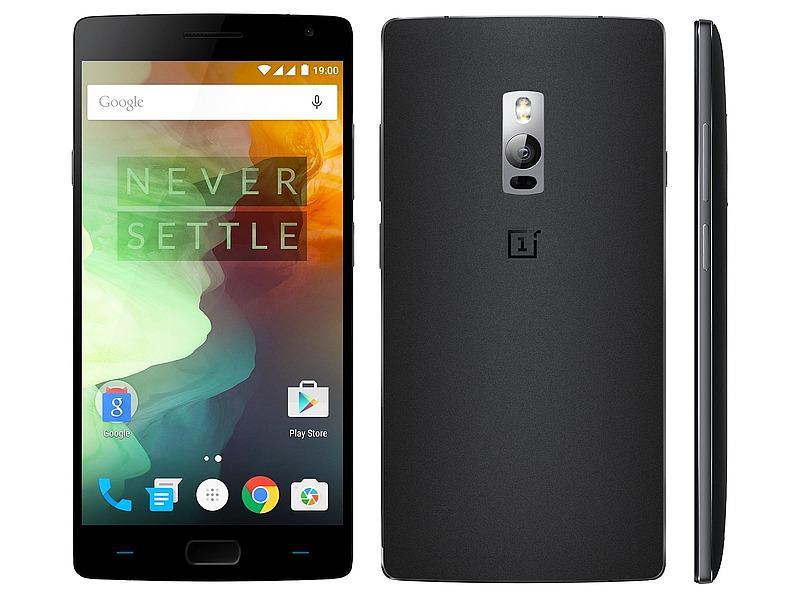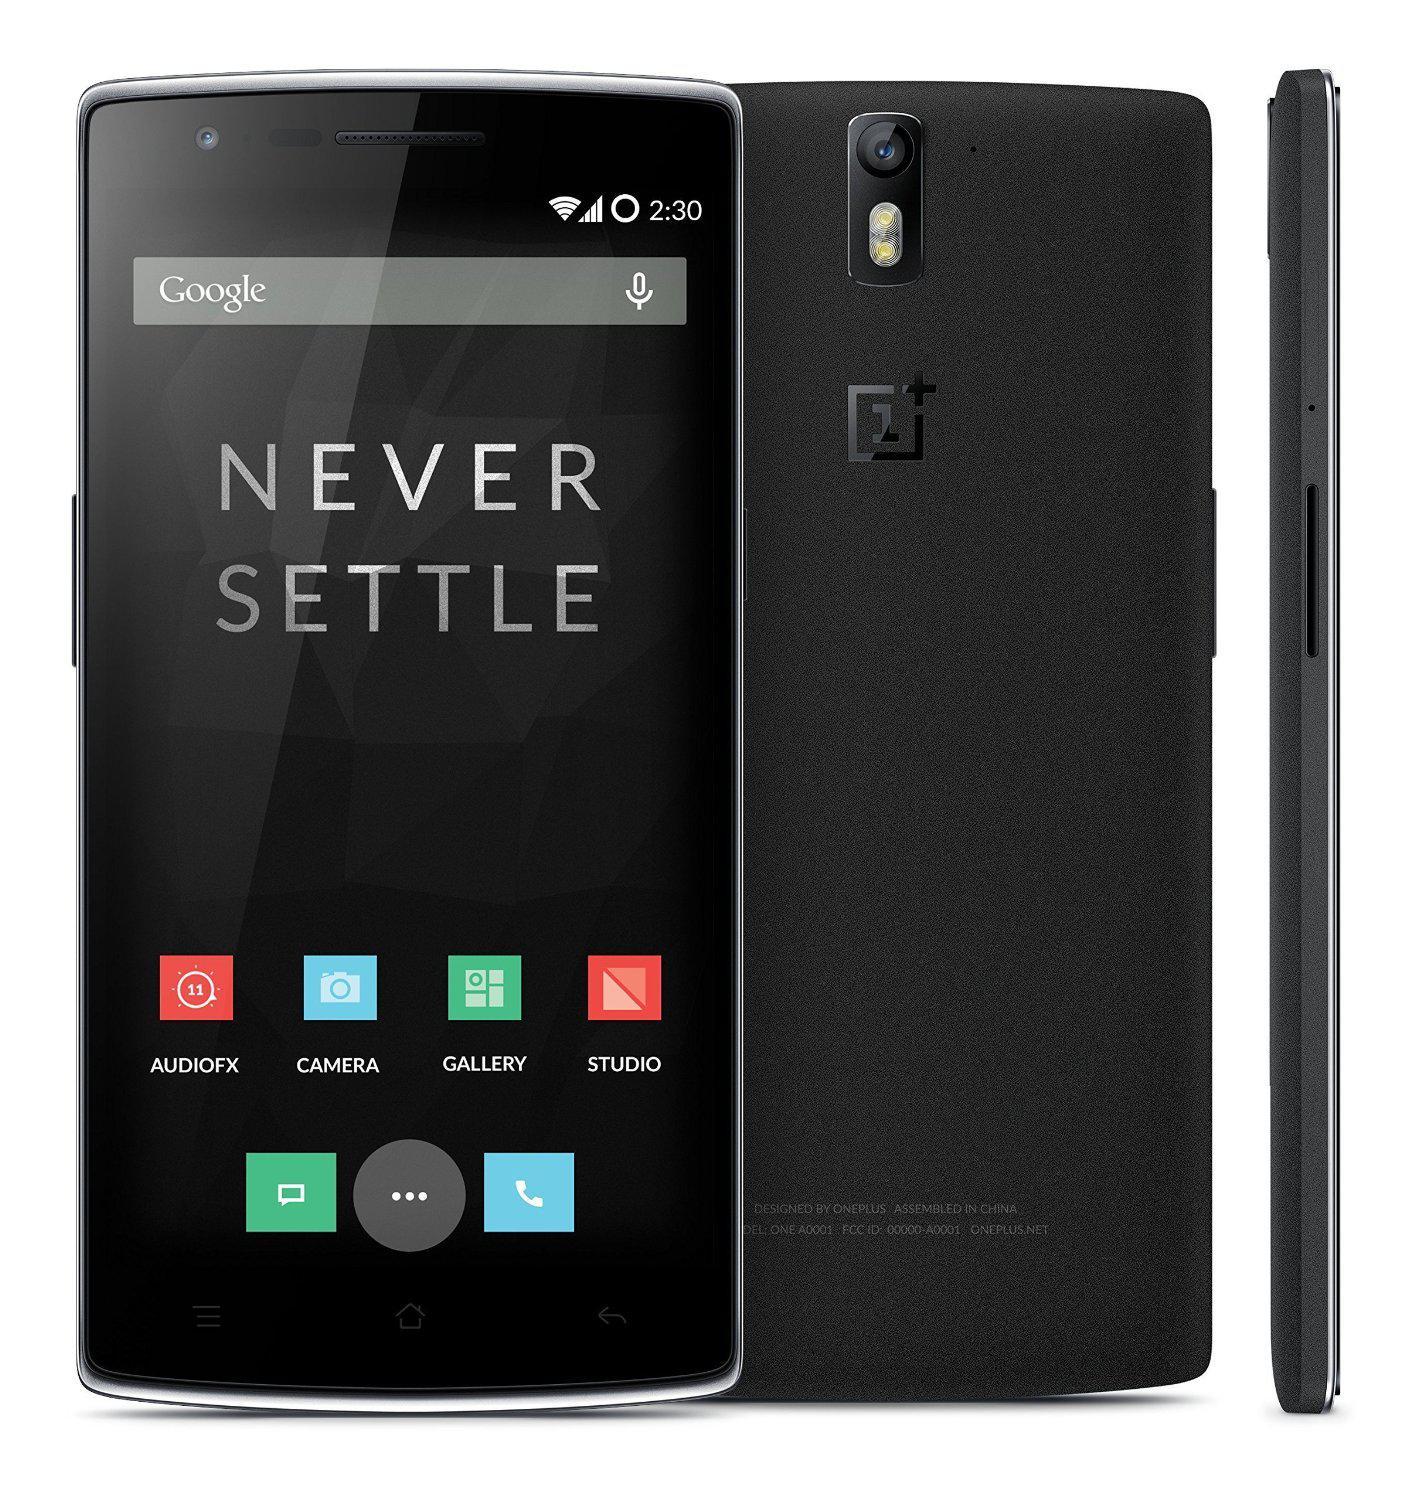The first image is the image on the left, the second image is the image on the right. Examine the images to the left and right. Is the description "At least one image features the side profile of a phone." accurate? Answer yes or no. Yes. The first image is the image on the left, the second image is the image on the right. Assess this claim about the two images: "The right image shows, in head-on view, a stylus to the right of a solid-colored device overlapped by the same shape with a screen on it.". Correct or not? Answer yes or no. Yes. 